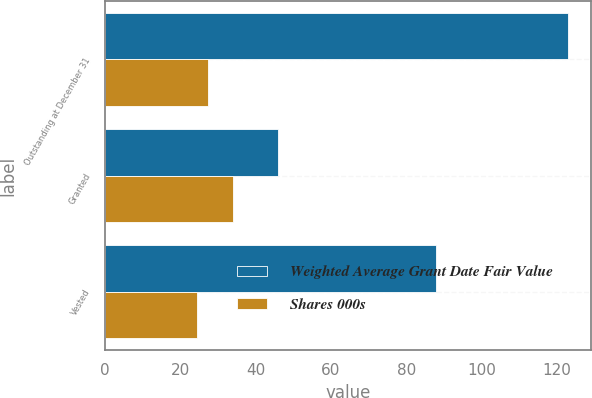Convert chart to OTSL. <chart><loc_0><loc_0><loc_500><loc_500><stacked_bar_chart><ecel><fcel>Outstanding at December 31<fcel>Granted<fcel>Vested<nl><fcel>Weighted Average Grant Date Fair Value<fcel>123<fcel>46<fcel>88<nl><fcel>Shares 000s<fcel>27.31<fcel>33.85<fcel>24.47<nl></chart> 